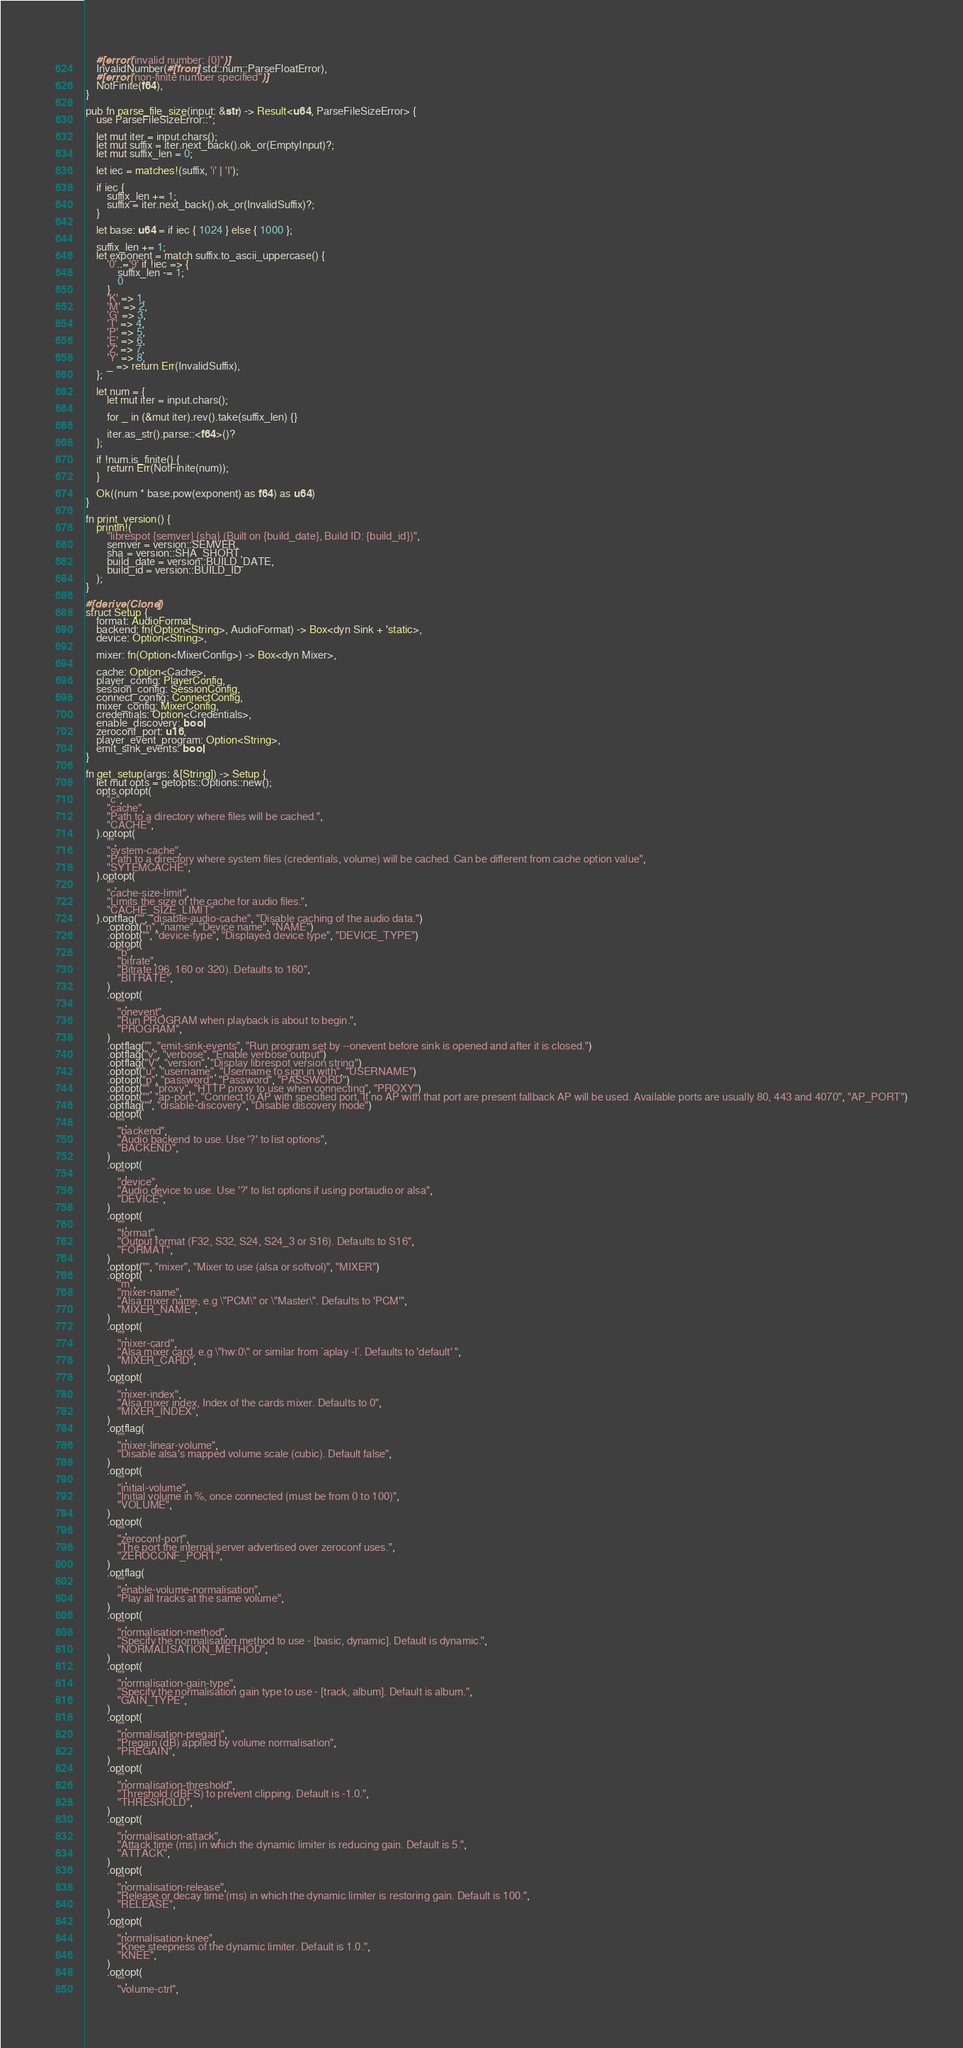Convert code to text. <code><loc_0><loc_0><loc_500><loc_500><_Rust_>    #[error("invalid number: {0}")]
    InvalidNumber(#[from] std::num::ParseFloatError),
    #[error("non-finite number specified")]
    NotFinite(f64),
}

pub fn parse_file_size(input: &str) -> Result<u64, ParseFileSizeError> {
    use ParseFileSizeError::*;

    let mut iter = input.chars();
    let mut suffix = iter.next_back().ok_or(EmptyInput)?;
    let mut suffix_len = 0;

    let iec = matches!(suffix, 'i' | 'I');

    if iec {
        suffix_len += 1;
        suffix = iter.next_back().ok_or(InvalidSuffix)?;
    }

    let base: u64 = if iec { 1024 } else { 1000 };

    suffix_len += 1;
    let exponent = match suffix.to_ascii_uppercase() {
        '0'..='9' if !iec => {
            suffix_len -= 1;
            0
        }
        'K' => 1,
        'M' => 2,
        'G' => 3,
        'T' => 4,
        'P' => 5,
        'E' => 6,
        'Z' => 7,
        'Y' => 8,
        _ => return Err(InvalidSuffix),
    };

    let num = {
        let mut iter = input.chars();

        for _ in (&mut iter).rev().take(suffix_len) {}

        iter.as_str().parse::<f64>()?
    };

    if !num.is_finite() {
        return Err(NotFinite(num));
    }

    Ok((num * base.pow(exponent) as f64) as u64)
}

fn print_version() {
    println!(
        "librespot {semver} {sha} (Built on {build_date}, Build ID: {build_id})",
        semver = version::SEMVER,
        sha = version::SHA_SHORT,
        build_date = version::BUILD_DATE,
        build_id = version::BUILD_ID
    );
}

#[derive(Clone)]
struct Setup {
    format: AudioFormat,
    backend: fn(Option<String>, AudioFormat) -> Box<dyn Sink + 'static>,
    device: Option<String>,

    mixer: fn(Option<MixerConfig>) -> Box<dyn Mixer>,

    cache: Option<Cache>,
    player_config: PlayerConfig,
    session_config: SessionConfig,
    connect_config: ConnectConfig,
    mixer_config: MixerConfig,
    credentials: Option<Credentials>,
    enable_discovery: bool,
    zeroconf_port: u16,
    player_event_program: Option<String>,
    emit_sink_events: bool,
}

fn get_setup(args: &[String]) -> Setup {
    let mut opts = getopts::Options::new();
    opts.optopt(
        "c",
        "cache",
        "Path to a directory where files will be cached.",
        "CACHE",
    ).optopt(
        "",
        "system-cache",
        "Path to a directory where system files (credentials, volume) will be cached. Can be different from cache option value",
        "SYTEMCACHE",
    ).optopt(
        "",
        "cache-size-limit",
        "Limits the size of the cache for audio files.",
        "CACHE_SIZE_LIMIT"
    ).optflag("", "disable-audio-cache", "Disable caching of the audio data.")
        .optopt("n", "name", "Device name", "NAME")
        .optopt("", "device-type", "Displayed device type", "DEVICE_TYPE")
        .optopt(
            "b",
            "bitrate",
            "Bitrate (96, 160 or 320). Defaults to 160",
            "BITRATE",
        )
        .optopt(
            "",
            "onevent",
            "Run PROGRAM when playback is about to begin.",
            "PROGRAM",
        )
        .optflag("", "emit-sink-events", "Run program set by --onevent before sink is opened and after it is closed.")
        .optflag("v", "verbose", "Enable verbose output")
        .optflag("V", "version", "Display librespot version string")
        .optopt("u", "username", "Username to sign in with", "USERNAME")
        .optopt("p", "password", "Password", "PASSWORD")
        .optopt("", "proxy", "HTTP proxy to use when connecting", "PROXY")
        .optopt("", "ap-port", "Connect to AP with specified port. If no AP with that port are present fallback AP will be used. Available ports are usually 80, 443 and 4070", "AP_PORT")
        .optflag("", "disable-discovery", "Disable discovery mode")
        .optopt(
            "",
            "backend",
            "Audio backend to use. Use '?' to list options",
            "BACKEND",
        )
        .optopt(
            "",
            "device",
            "Audio device to use. Use '?' to list options if using portaudio or alsa",
            "DEVICE",
        )
        .optopt(
            "",
            "format",
            "Output format (F32, S32, S24, S24_3 or S16). Defaults to S16",
            "FORMAT",
        )
        .optopt("", "mixer", "Mixer to use (alsa or softvol)", "MIXER")
        .optopt(
            "m",
            "mixer-name",
            "Alsa mixer name, e.g \"PCM\" or \"Master\". Defaults to 'PCM'",
            "MIXER_NAME",
        )
        .optopt(
            "",
            "mixer-card",
            "Alsa mixer card, e.g \"hw:0\" or similar from `aplay -l`. Defaults to 'default' ",
            "MIXER_CARD",
        )
        .optopt(
            "",
            "mixer-index",
            "Alsa mixer index, Index of the cards mixer. Defaults to 0",
            "MIXER_INDEX",
        )
        .optflag(
            "",
            "mixer-linear-volume",
            "Disable alsa's mapped volume scale (cubic). Default false",
        )
        .optopt(
            "",
            "initial-volume",
            "Initial volume in %, once connected (must be from 0 to 100)",
            "VOLUME",
        )
        .optopt(
            "",
            "zeroconf-port",
            "The port the internal server advertised over zeroconf uses.",
            "ZEROCONF_PORT",
        )
        .optflag(
            "",
            "enable-volume-normalisation",
            "Play all tracks at the same volume",
        )
        .optopt(
            "",
            "normalisation-method",
            "Specify the normalisation method to use - [basic, dynamic]. Default is dynamic.",
            "NORMALISATION_METHOD",
        )
        .optopt(
            "",
            "normalisation-gain-type",
            "Specify the normalisation gain type to use - [track, album]. Default is album.",
            "GAIN_TYPE",
        )
        .optopt(
            "",
            "normalisation-pregain",
            "Pregain (dB) applied by volume normalisation",
            "PREGAIN",
        )
        .optopt(
            "",
            "normalisation-threshold",
            "Threshold (dBFS) to prevent clipping. Default is -1.0.",
            "THRESHOLD",
        )
        .optopt(
            "",
            "normalisation-attack",
            "Attack time (ms) in which the dynamic limiter is reducing gain. Default is 5.",
            "ATTACK",
        )
        .optopt(
            "",
            "normalisation-release",
            "Release or decay time (ms) in which the dynamic limiter is restoring gain. Default is 100.",
            "RELEASE",
        )
        .optopt(
            "",
            "normalisation-knee",
            "Knee steepness of the dynamic limiter. Default is 1.0.",
            "KNEE",
        )
        .optopt(
            "",
            "volume-ctrl",</code> 